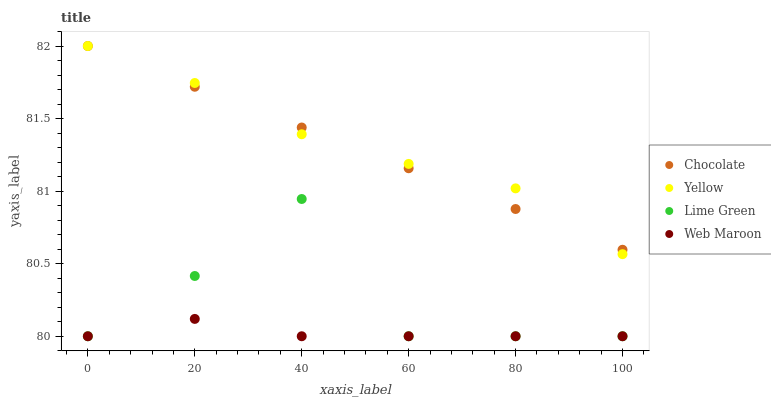Does Web Maroon have the minimum area under the curve?
Answer yes or no. Yes. Does Yellow have the maximum area under the curve?
Answer yes or no. Yes. Does Lime Green have the minimum area under the curve?
Answer yes or no. No. Does Lime Green have the maximum area under the curve?
Answer yes or no. No. Is Chocolate the smoothest?
Answer yes or no. Yes. Is Lime Green the roughest?
Answer yes or no. Yes. Is Yellow the smoothest?
Answer yes or no. No. Is Yellow the roughest?
Answer yes or no. No. Does Web Maroon have the lowest value?
Answer yes or no. Yes. Does Yellow have the lowest value?
Answer yes or no. No. Does Chocolate have the highest value?
Answer yes or no. Yes. Does Lime Green have the highest value?
Answer yes or no. No. Is Web Maroon less than Yellow?
Answer yes or no. Yes. Is Chocolate greater than Web Maroon?
Answer yes or no. Yes. Does Lime Green intersect Web Maroon?
Answer yes or no. Yes. Is Lime Green less than Web Maroon?
Answer yes or no. No. Is Lime Green greater than Web Maroon?
Answer yes or no. No. Does Web Maroon intersect Yellow?
Answer yes or no. No. 